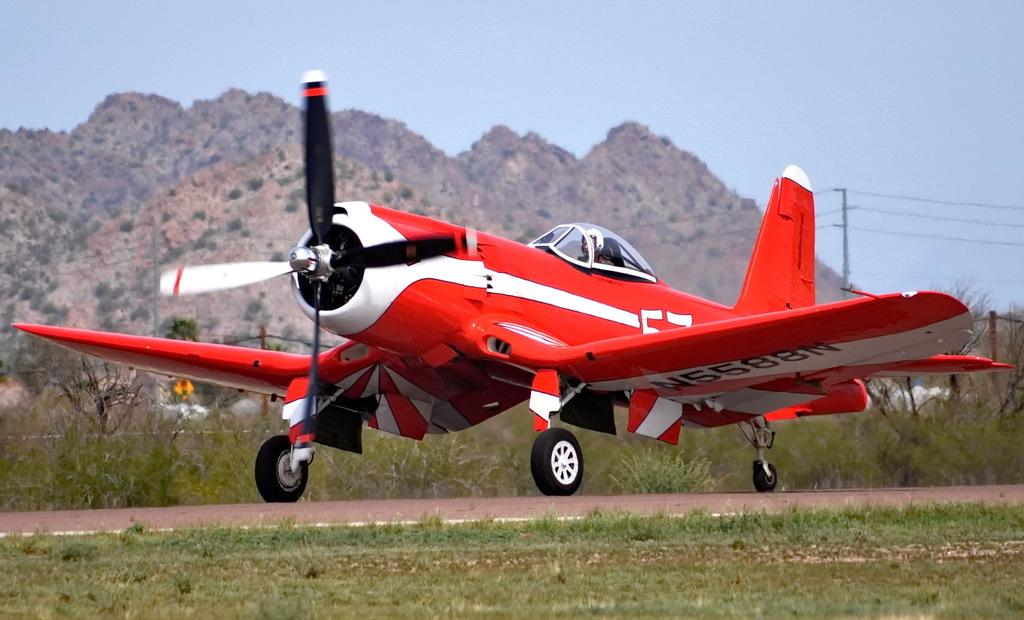<image>
Create a compact narrative representing the image presented. A red and white propeller airplane with N5588N on its wing 